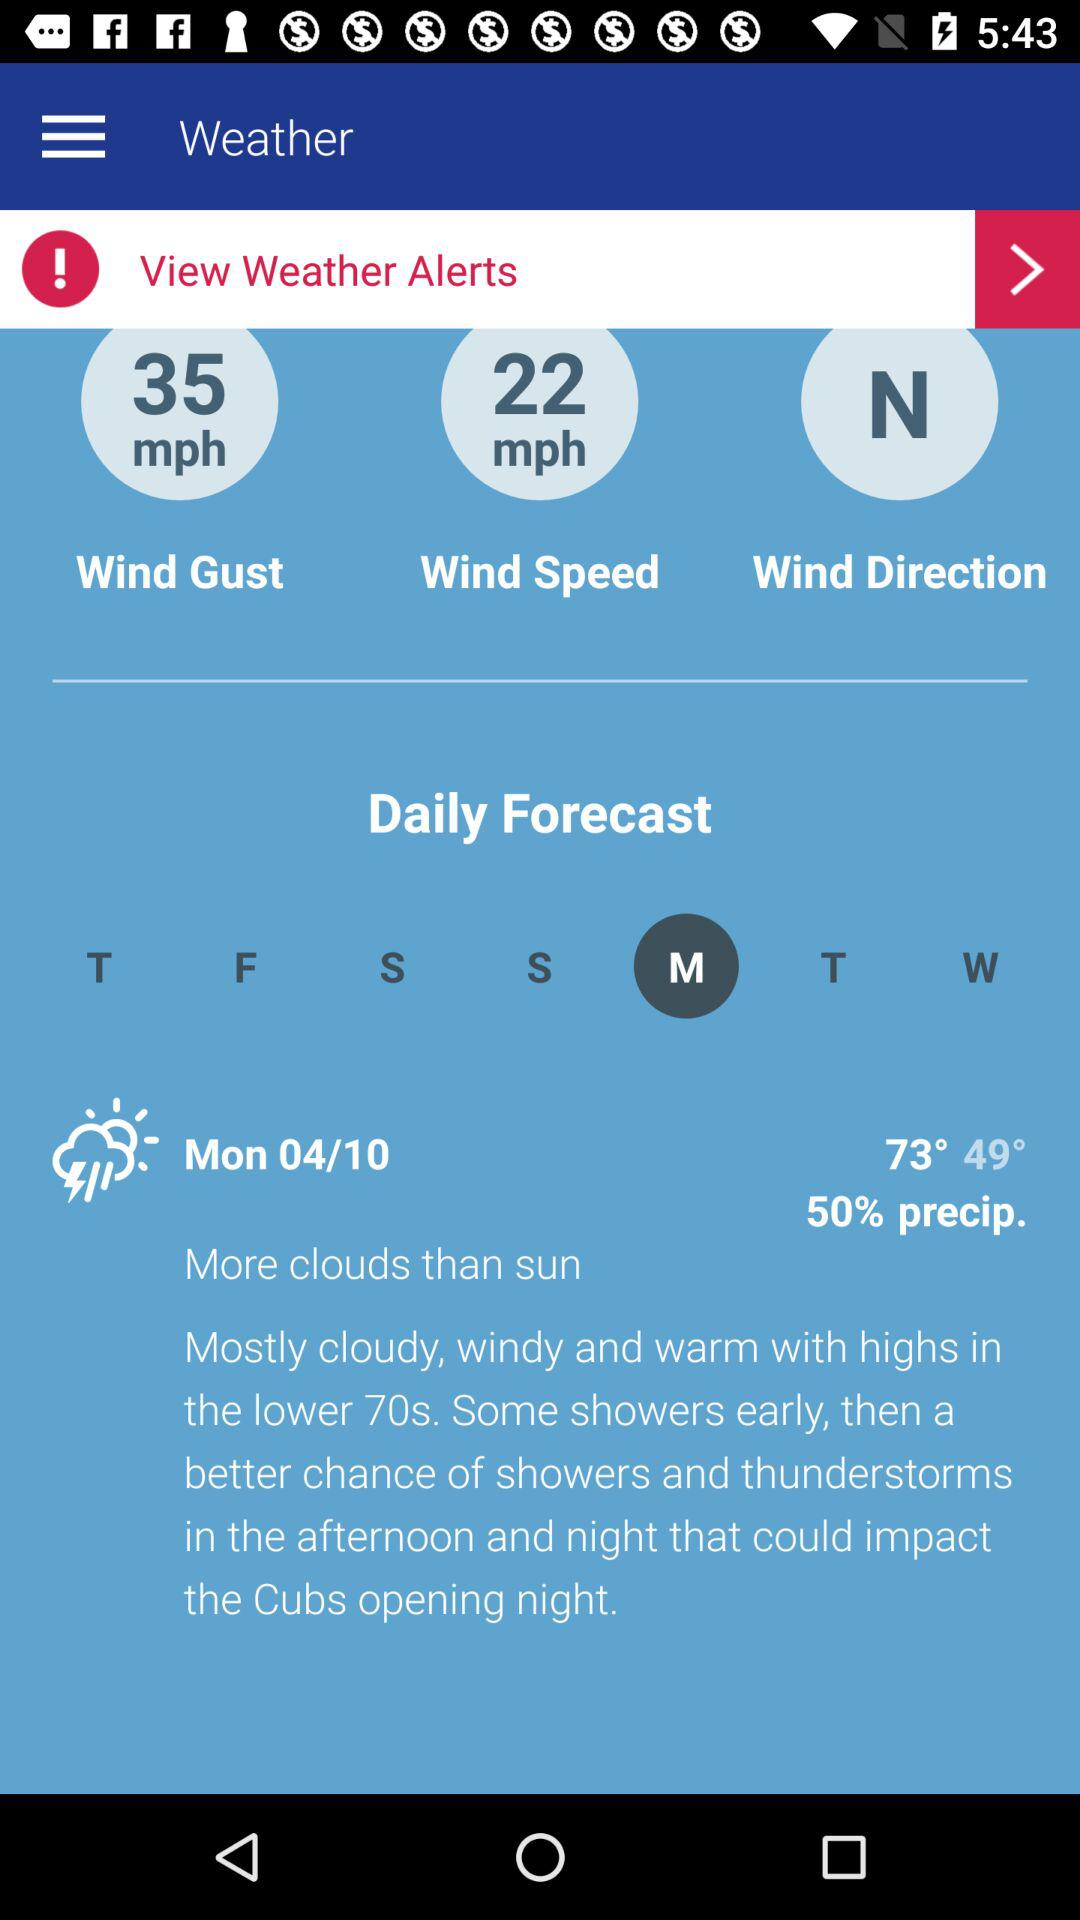What is the wind speed in mph?
Answer the question using a single word or phrase. 22 mph 